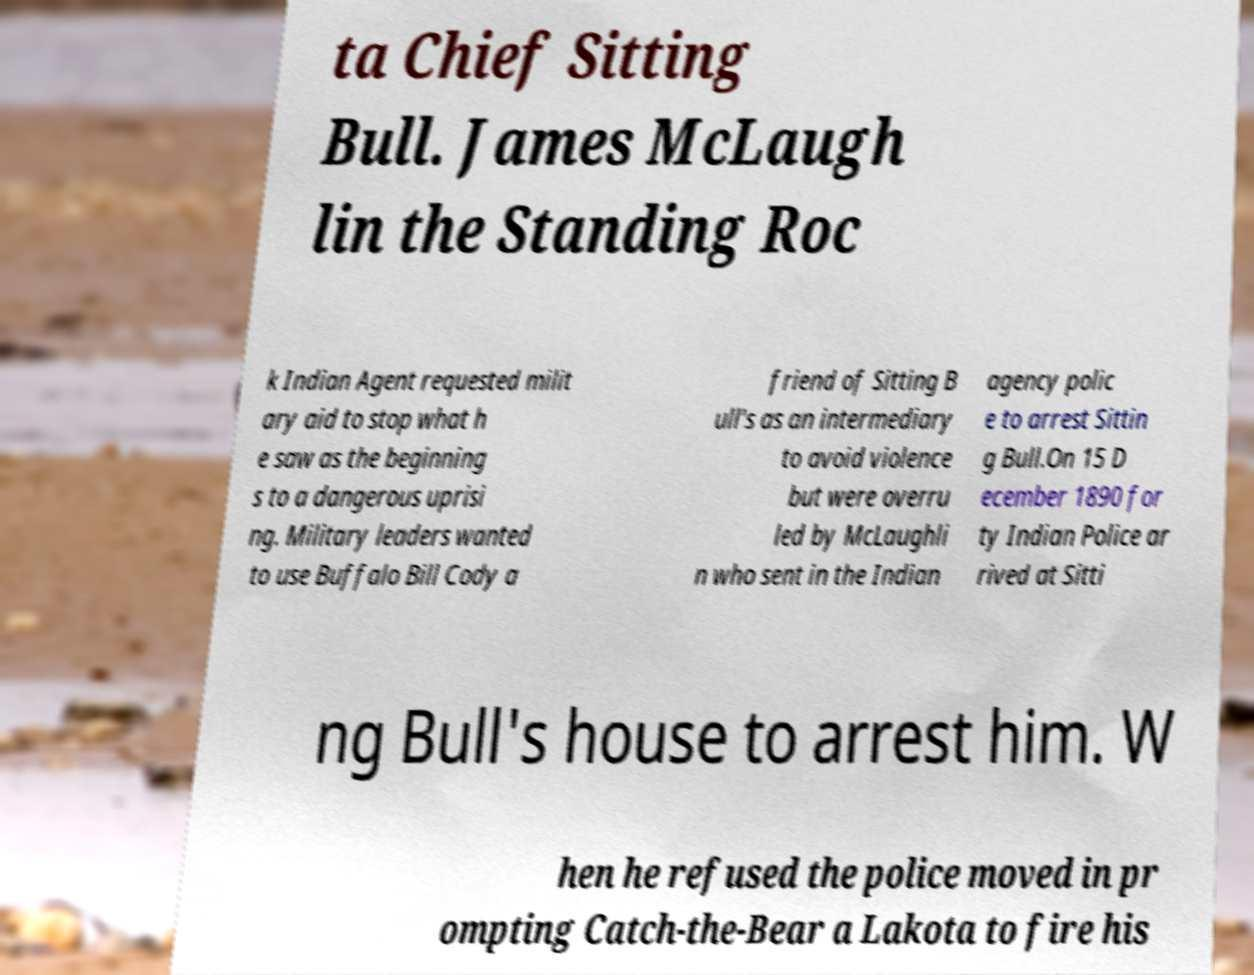Could you extract and type out the text from this image? ta Chief Sitting Bull. James McLaugh lin the Standing Roc k Indian Agent requested milit ary aid to stop what h e saw as the beginning s to a dangerous uprisi ng. Military leaders wanted to use Buffalo Bill Cody a friend of Sitting B ull's as an intermediary to avoid violence but were overru led by McLaughli n who sent in the Indian agency polic e to arrest Sittin g Bull.On 15 D ecember 1890 for ty Indian Police ar rived at Sitti ng Bull's house to arrest him. W hen he refused the police moved in pr ompting Catch-the-Bear a Lakota to fire his 